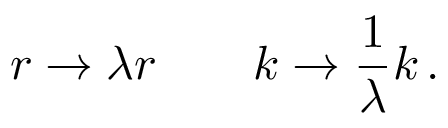Convert formula to latex. <formula><loc_0><loc_0><loc_500><loc_500>r \rightarrow \lambda r \quad k \rightarrow { \frac { 1 } { \lambda } } k \, .</formula> 